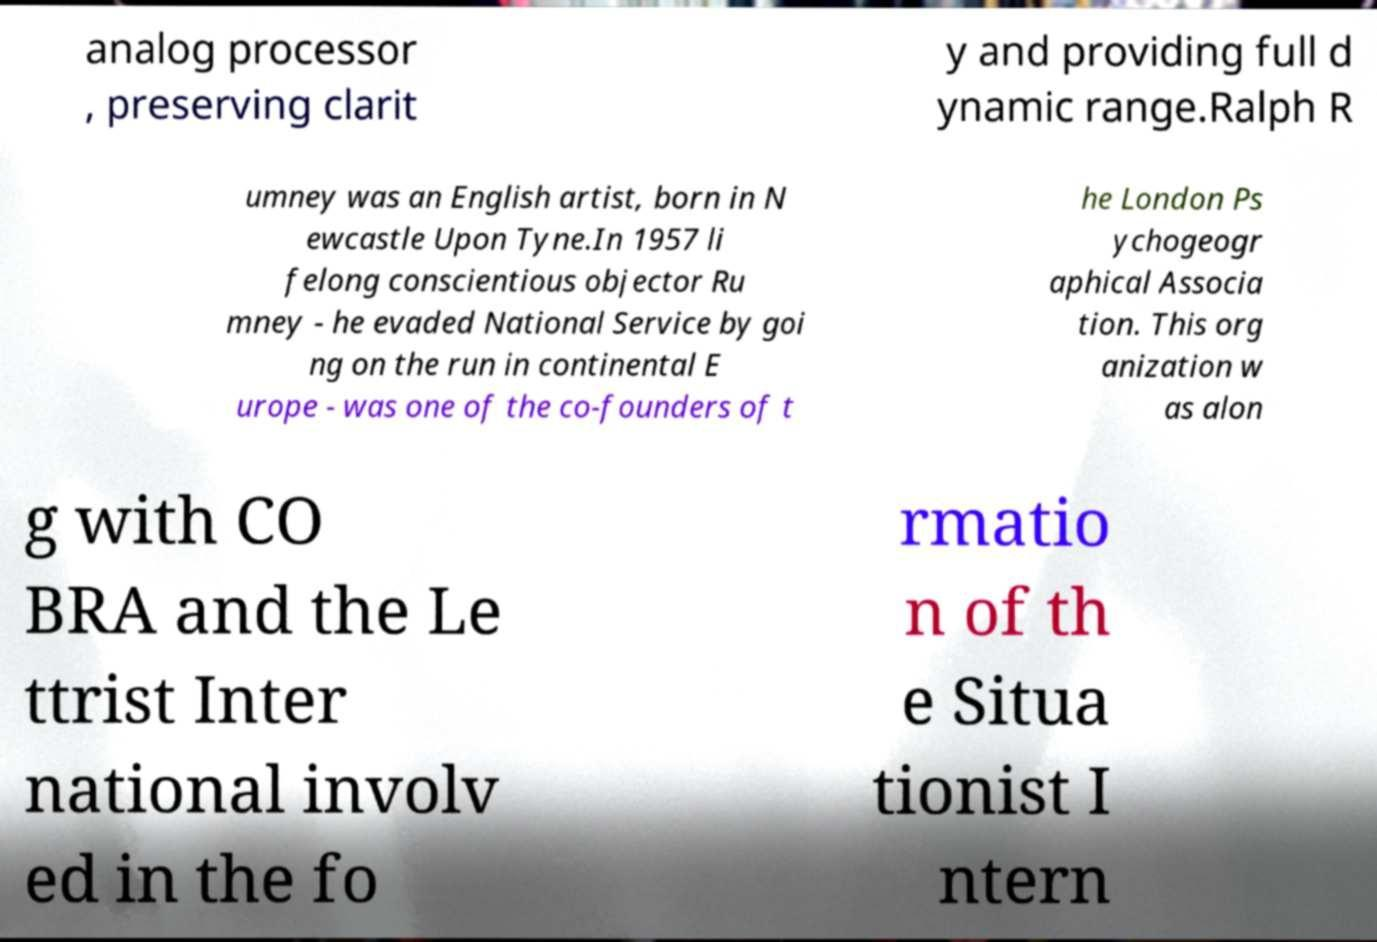I need the written content from this picture converted into text. Can you do that? analog processor , preserving clarit y and providing full d ynamic range.Ralph R umney was an English artist, born in N ewcastle Upon Tyne.In 1957 li felong conscientious objector Ru mney - he evaded National Service by goi ng on the run in continental E urope - was one of the co-founders of t he London Ps ychogeogr aphical Associa tion. This org anization w as alon g with CO BRA and the Le ttrist Inter national involv ed in the fo rmatio n of th e Situa tionist I ntern 